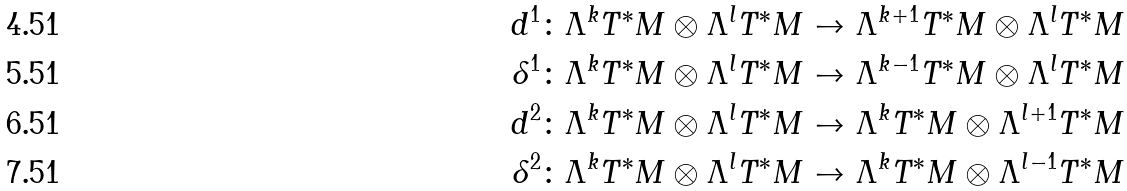Convert formula to latex. <formula><loc_0><loc_0><loc_500><loc_500>d ^ { 1 } & \colon \Lambda ^ { k } T ^ { \ast } M \otimes \Lambda ^ { l } T ^ { \ast } M \to \Lambda ^ { k + 1 } T ^ { \ast } M \otimes \Lambda ^ { l } T ^ { \ast } M \\ \delta ^ { 1 } & \colon \Lambda ^ { k } T ^ { \ast } M \otimes \Lambda ^ { l } T ^ { \ast } M \to \Lambda ^ { k - 1 } T ^ { \ast } M \otimes \Lambda ^ { l } T ^ { \ast } M \\ d ^ { 2 } & \colon \Lambda ^ { k } T ^ { \ast } M \otimes \Lambda ^ { l } T ^ { \ast } M \to \Lambda ^ { k } T ^ { \ast } M \otimes \Lambda ^ { l + 1 } T ^ { \ast } M \\ \delta ^ { 2 } & \colon \Lambda ^ { k } T ^ { \ast } M \otimes \Lambda ^ { l } T ^ { \ast } M \to \Lambda ^ { k } T ^ { \ast } M \otimes \Lambda ^ { l - 1 } T ^ { \ast } M</formula> 